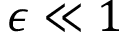Convert formula to latex. <formula><loc_0><loc_0><loc_500><loc_500>\epsilon \ll 1</formula> 